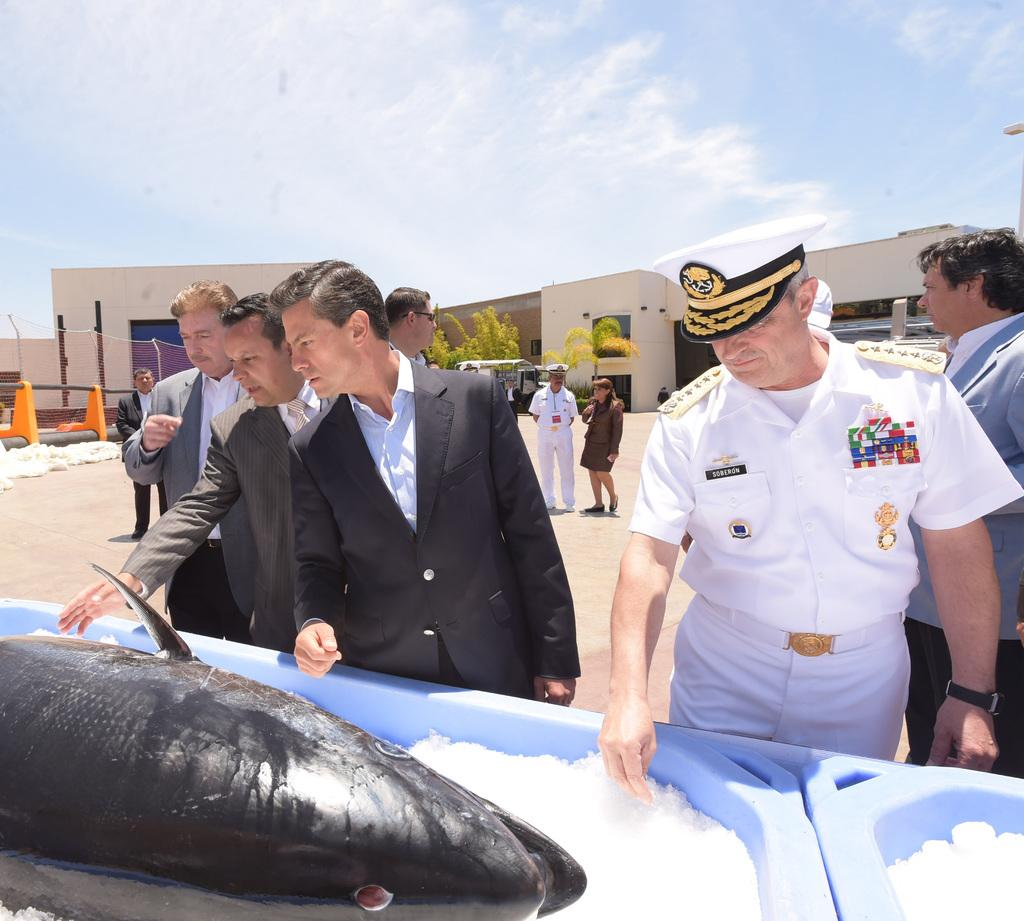What is inside the ice box in the image? There is a fish in an ice box in the image. What can be seen in the background of the image? There are people standing and buildings visible in the background of the image. What is visible in the sky in the image? The sky is visible in the background of the image. How many eggs are being stored in the can in the image? There is no can or eggs present in the image. Are there any babies visible in the image? There are no babies visible in the image. 